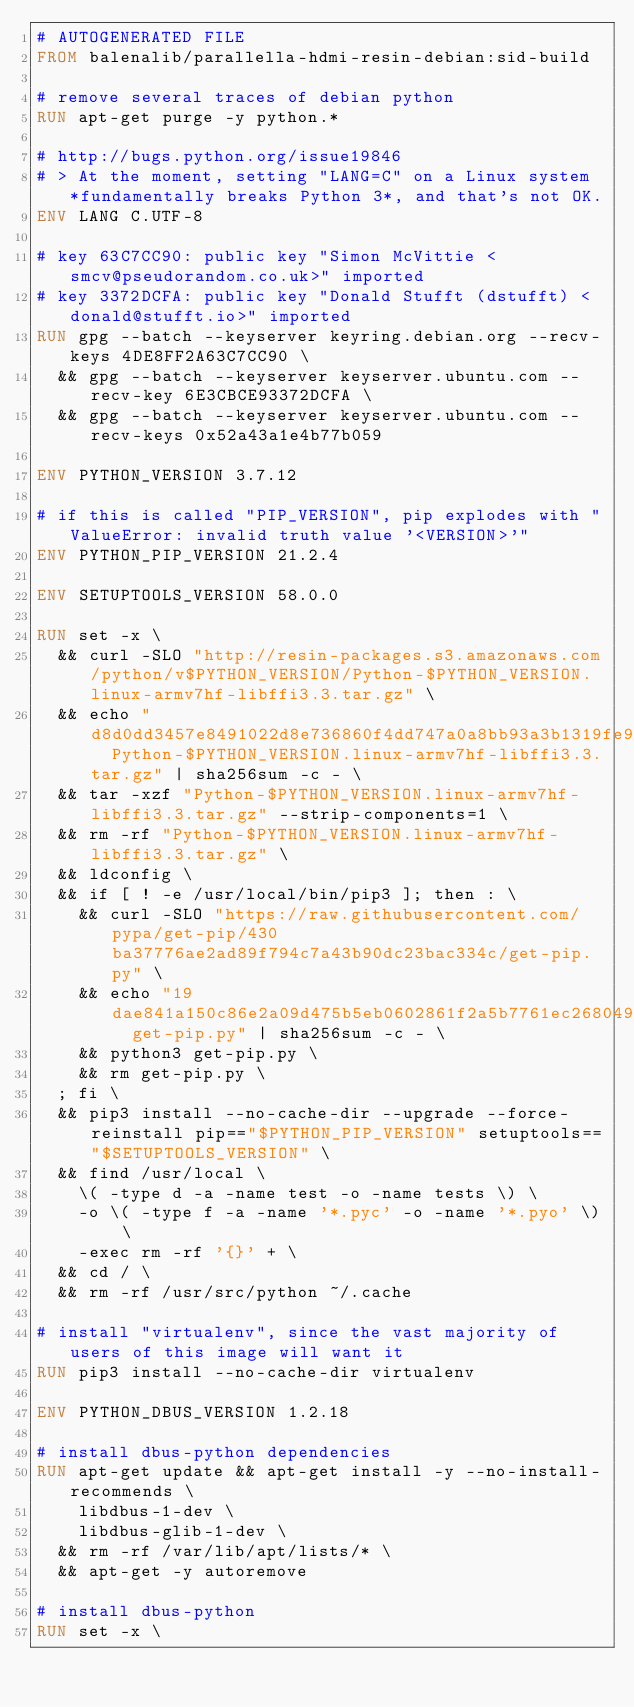<code> <loc_0><loc_0><loc_500><loc_500><_Dockerfile_># AUTOGENERATED FILE
FROM balenalib/parallella-hdmi-resin-debian:sid-build

# remove several traces of debian python
RUN apt-get purge -y python.*

# http://bugs.python.org/issue19846
# > At the moment, setting "LANG=C" on a Linux system *fundamentally breaks Python 3*, and that's not OK.
ENV LANG C.UTF-8

# key 63C7CC90: public key "Simon McVittie <smcv@pseudorandom.co.uk>" imported
# key 3372DCFA: public key "Donald Stufft (dstufft) <donald@stufft.io>" imported
RUN gpg --batch --keyserver keyring.debian.org --recv-keys 4DE8FF2A63C7CC90 \
	&& gpg --batch --keyserver keyserver.ubuntu.com --recv-key 6E3CBCE93372DCFA \
	&& gpg --batch --keyserver keyserver.ubuntu.com --recv-keys 0x52a43a1e4b77b059

ENV PYTHON_VERSION 3.7.12

# if this is called "PIP_VERSION", pip explodes with "ValueError: invalid truth value '<VERSION>'"
ENV PYTHON_PIP_VERSION 21.2.4

ENV SETUPTOOLS_VERSION 58.0.0

RUN set -x \
	&& curl -SLO "http://resin-packages.s3.amazonaws.com/python/v$PYTHON_VERSION/Python-$PYTHON_VERSION.linux-armv7hf-libffi3.3.tar.gz" \
	&& echo "d8d0dd3457e8491022d8e736860f4dd747a0a8bb93a3b1319fe9d2610b0006b0  Python-$PYTHON_VERSION.linux-armv7hf-libffi3.3.tar.gz" | sha256sum -c - \
	&& tar -xzf "Python-$PYTHON_VERSION.linux-armv7hf-libffi3.3.tar.gz" --strip-components=1 \
	&& rm -rf "Python-$PYTHON_VERSION.linux-armv7hf-libffi3.3.tar.gz" \
	&& ldconfig \
	&& if [ ! -e /usr/local/bin/pip3 ]; then : \
		&& curl -SLO "https://raw.githubusercontent.com/pypa/get-pip/430ba37776ae2ad89f794c7a43b90dc23bac334c/get-pip.py" \
		&& echo "19dae841a150c86e2a09d475b5eb0602861f2a5b7761ec268049a662dbd2bd0c  get-pip.py" | sha256sum -c - \
		&& python3 get-pip.py \
		&& rm get-pip.py \
	; fi \
	&& pip3 install --no-cache-dir --upgrade --force-reinstall pip=="$PYTHON_PIP_VERSION" setuptools=="$SETUPTOOLS_VERSION" \
	&& find /usr/local \
		\( -type d -a -name test -o -name tests \) \
		-o \( -type f -a -name '*.pyc' -o -name '*.pyo' \) \
		-exec rm -rf '{}' + \
	&& cd / \
	&& rm -rf /usr/src/python ~/.cache

# install "virtualenv", since the vast majority of users of this image will want it
RUN pip3 install --no-cache-dir virtualenv

ENV PYTHON_DBUS_VERSION 1.2.18

# install dbus-python dependencies 
RUN apt-get update && apt-get install -y --no-install-recommends \
		libdbus-1-dev \
		libdbus-glib-1-dev \
	&& rm -rf /var/lib/apt/lists/* \
	&& apt-get -y autoremove

# install dbus-python
RUN set -x \</code> 